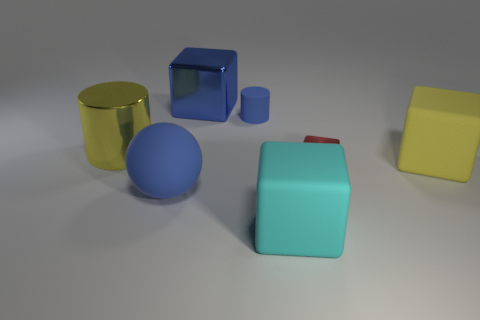Are there more large blue metal blocks that are right of the cyan cube than big red matte balls?
Give a very brief answer. No. Are there any other things that are the same color as the large sphere?
Ensure brevity in your answer.  Yes. There is a small blue object that is the same material as the yellow block; what is its shape?
Your response must be concise. Cylinder. Do the large thing that is left of the large blue rubber ball and the small cube have the same material?
Your answer should be compact. Yes. What is the shape of the tiny object that is the same color as the big metal block?
Offer a terse response. Cylinder. Is the color of the shiny cube left of the red shiny thing the same as the cylinder in front of the blue cylinder?
Keep it short and to the point. No. What number of things are behind the big yellow cube and on the right side of the big blue rubber sphere?
Your answer should be compact. 2. What material is the small red cube?
Give a very brief answer. Metal. There is a red metal thing that is the same size as the blue rubber cylinder; what is its shape?
Offer a very short reply. Cube. Does the big blue block that is on the left side of the large cyan thing have the same material as the tiny thing that is in front of the tiny blue rubber cylinder?
Give a very brief answer. Yes. 